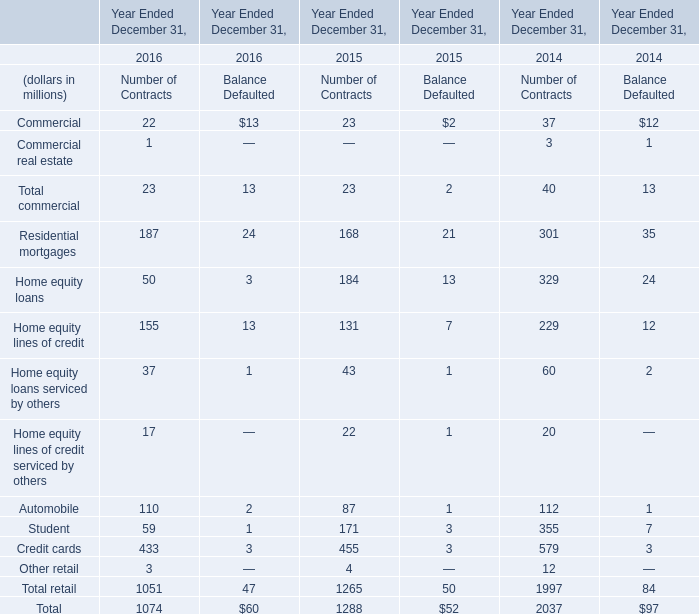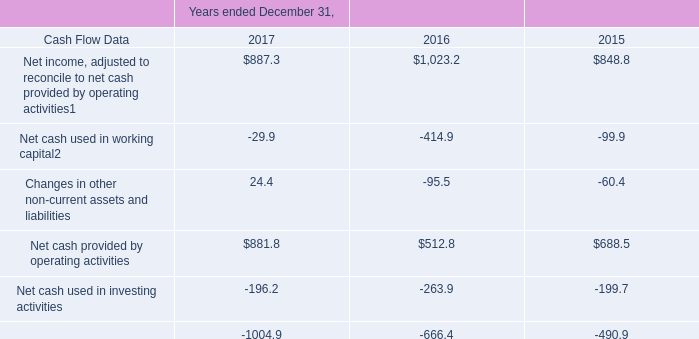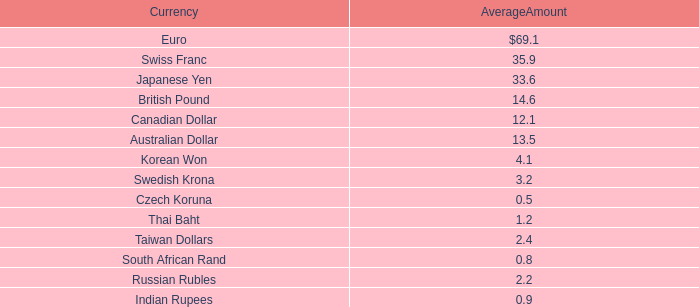what was the total amount of corporate and other expenses from 2015-2017? 
Computations: ((147.2 + (147.2 - 5.4)) + 126.6)
Answer: 415.6. 